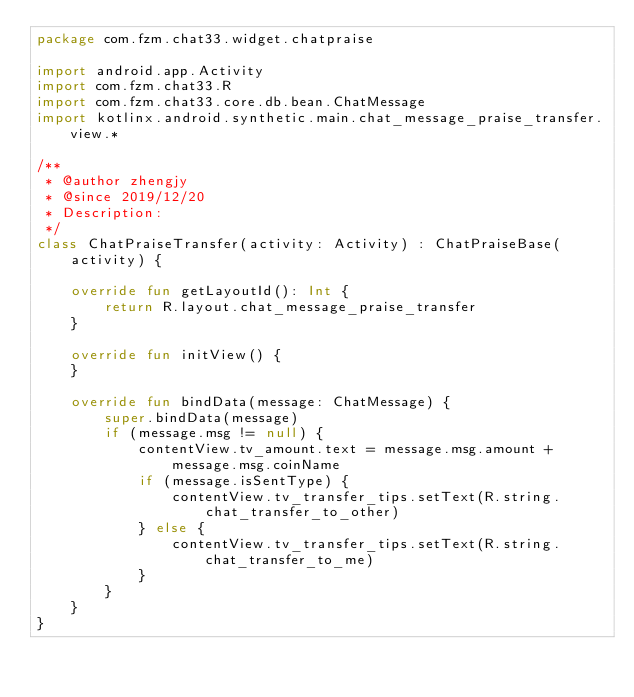<code> <loc_0><loc_0><loc_500><loc_500><_Kotlin_>package com.fzm.chat33.widget.chatpraise

import android.app.Activity
import com.fzm.chat33.R
import com.fzm.chat33.core.db.bean.ChatMessage
import kotlinx.android.synthetic.main.chat_message_praise_transfer.view.*

/**
 * @author zhengjy
 * @since 2019/12/20
 * Description:
 */
class ChatPraiseTransfer(activity: Activity) : ChatPraiseBase(activity) {

    override fun getLayoutId(): Int {
        return R.layout.chat_message_praise_transfer
    }

    override fun initView() {
    }

    override fun bindData(message: ChatMessage) {
        super.bindData(message)
        if (message.msg != null) {
            contentView.tv_amount.text = message.msg.amount + message.msg.coinName
            if (message.isSentType) {
                contentView.tv_transfer_tips.setText(R.string.chat_transfer_to_other)
            } else {
                contentView.tv_transfer_tips.setText(R.string.chat_transfer_to_me)
            }
        }
    }
}</code> 